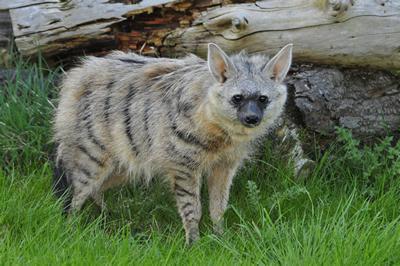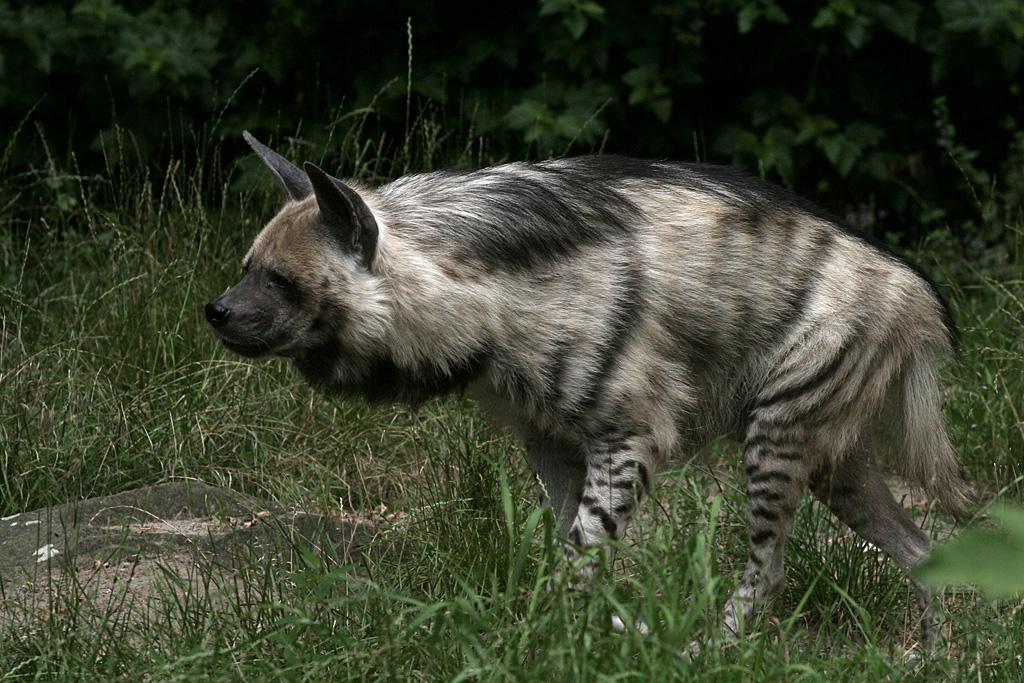The first image is the image on the left, the second image is the image on the right. Analyze the images presented: Is the assertion "Right image shows a hyena with nothing in its mouth." valid? Answer yes or no. Yes. The first image is the image on the left, the second image is the image on the right. Evaluate the accuracy of this statement regarding the images: "1 hyena with no prey in its mouth is walking toward the left.". Is it true? Answer yes or no. Yes. 